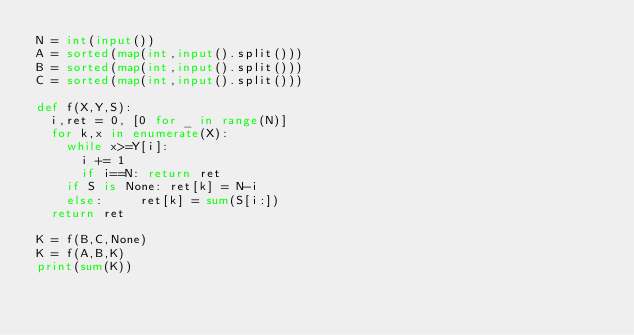<code> <loc_0><loc_0><loc_500><loc_500><_Python_>N = int(input())
A = sorted(map(int,input().split()))
B = sorted(map(int,input().split()))
C = sorted(map(int,input().split()))

def f(X,Y,S):
	i,ret = 0, [0 for _ in range(N)]
	for k,x in enumerate(X):
		while x>=Y[i]:
			i += 1
			if i==N: return ret
		if S is None:	ret[k] = N-i
		else:			ret[k] = sum(S[i:])
	return ret

K = f(B,C,None)
K = f(A,B,K)
print(sum(K))
</code> 